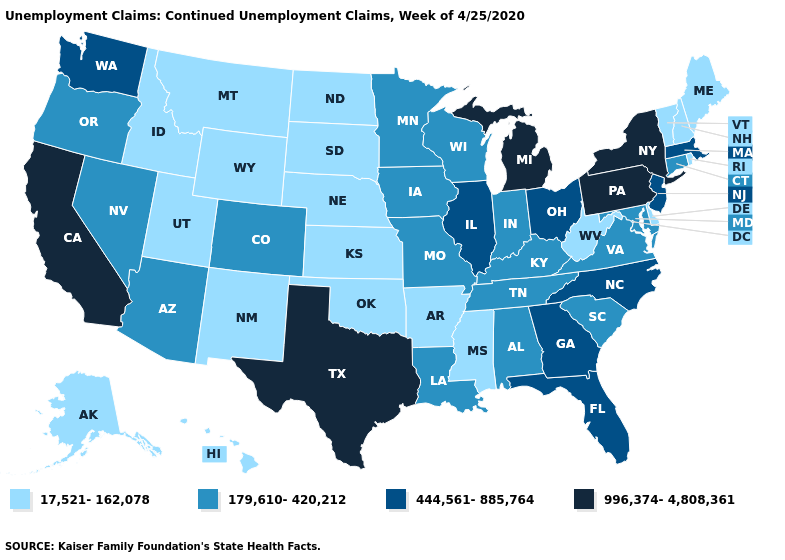What is the lowest value in states that border Utah?
Write a very short answer. 17,521-162,078. What is the highest value in states that border Tennessee?
Short answer required. 444,561-885,764. Name the states that have a value in the range 17,521-162,078?
Concise answer only. Alaska, Arkansas, Delaware, Hawaii, Idaho, Kansas, Maine, Mississippi, Montana, Nebraska, New Hampshire, New Mexico, North Dakota, Oklahoma, Rhode Island, South Dakota, Utah, Vermont, West Virginia, Wyoming. Does North Carolina have a lower value than Oklahoma?
Keep it brief. No. Among the states that border New Mexico , which have the lowest value?
Be succinct. Oklahoma, Utah. How many symbols are there in the legend?
Answer briefly. 4. What is the value of New York?
Quick response, please. 996,374-4,808,361. Which states have the highest value in the USA?
Concise answer only. California, Michigan, New York, Pennsylvania, Texas. Does Indiana have a lower value than Rhode Island?
Quick response, please. No. What is the lowest value in the USA?
Short answer required. 17,521-162,078. Among the states that border Arkansas , does Oklahoma have the lowest value?
Give a very brief answer. Yes. Among the states that border Missouri , does Illinois have the highest value?
Be succinct. Yes. Is the legend a continuous bar?
Write a very short answer. No. What is the lowest value in states that border Minnesota?
Be succinct. 17,521-162,078. Name the states that have a value in the range 17,521-162,078?
Concise answer only. Alaska, Arkansas, Delaware, Hawaii, Idaho, Kansas, Maine, Mississippi, Montana, Nebraska, New Hampshire, New Mexico, North Dakota, Oklahoma, Rhode Island, South Dakota, Utah, Vermont, West Virginia, Wyoming. 